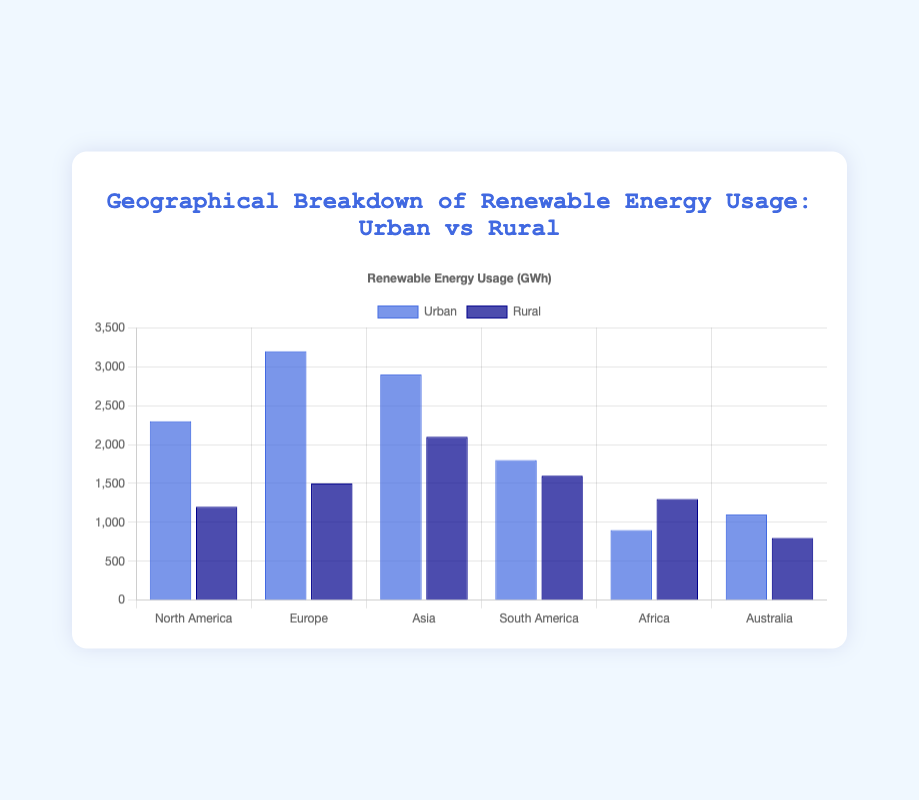What region has the highest renewable energy usage in Urban areas? The highest bar in the Urban dataset on the chart is for Europe.
Answer: Europe Which region has a higher renewable energy usage in Rural areas, Asia or Africa? Compare the heights of the Rural bars for Asia and Africa. Asia's bar is higher than Africa's.
Answer: Asia What is the total renewable energy usage for South America? Sum the renewable energy usage in Urban (1800 GWh) and Rural (1600 GWh) areas in South America. 1800 + 1600 = 3400 GWh
Answer: 3400 GWh In which area type (Urban or Rural) does Australia have higher renewable energy usage? Compare the heights of the Urban and Rural bars for Australia. The Urban bar is higher than the Rural.
Answer: Urban What is the difference in renewable energy usage between Urban and Rural areas in North America? Subtract the Rural usage (1200 GWh) from the Urban usage (2300 GWh) for North America. 2300 - 1200 = 1100 GWh
Answer: 1100 GWh Which region has the lowest renewable energy usage in Urban areas? The shortest bar in the Urban dataset on the chart is for Africa.
Answer: Africa Calculate the average renewable energy usage for Urban areas across all regions. Add the Urban usages: 2300 + 3200 + 2900 + 1800 + 900 + 1100 = 12200 GWh. Divide by the number of regions (6): 12200 / 6 ≈ 2033.33 GWh
Answer: 2033.33 GWh Is the renewable energy usage for Rural areas in Australia lower than Urban areas in Africa? Compare the heights of the Rural bar for Australia and the Urban bar for Africa. Australia's Rural bar (800 GWh) is lower than Africa's Urban bar (900 GWh).
Answer: Yes Compare the total renewable energy usage between Europe and Africa. For Europe, sum Urban (3200 GWh) and Rural (1500 GWh): 3200 + 1500 = 4700 GWh. For Africa, sum Urban (900 GWh) and Rural (1300 GWh): 900 + 1300 = 2200 GWh. Europe has higher usage.
Answer: Europe What is the combined renewable energy usage for Urban areas in North America and Asia? Sum the Urban usages for North America (2300 GWh) and Asia (2900 GWh): 2300 + 2900 = 5200 GWh.
Answer: 5200 GWh 